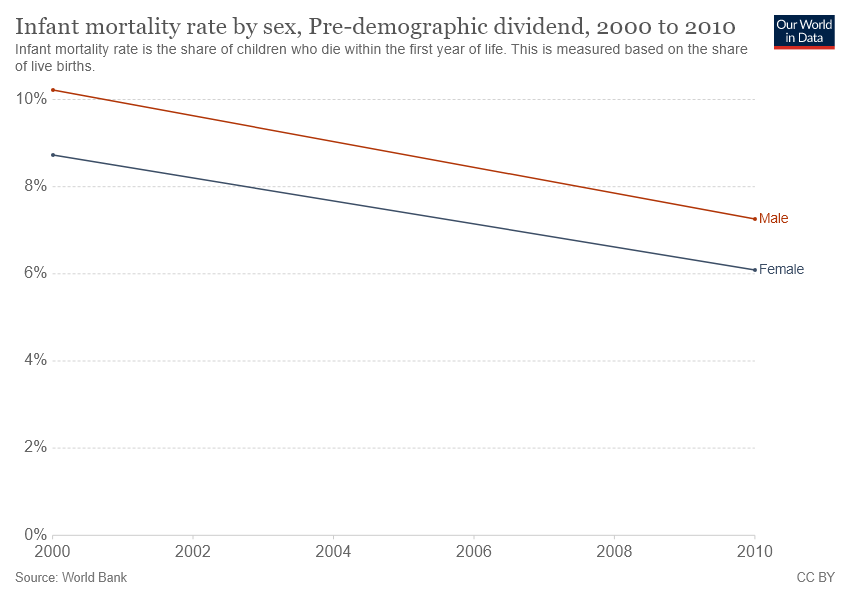Outline some significant characteristics in this image. The fact that the average for males is always higher than the average for females is true. Six years are represented. 